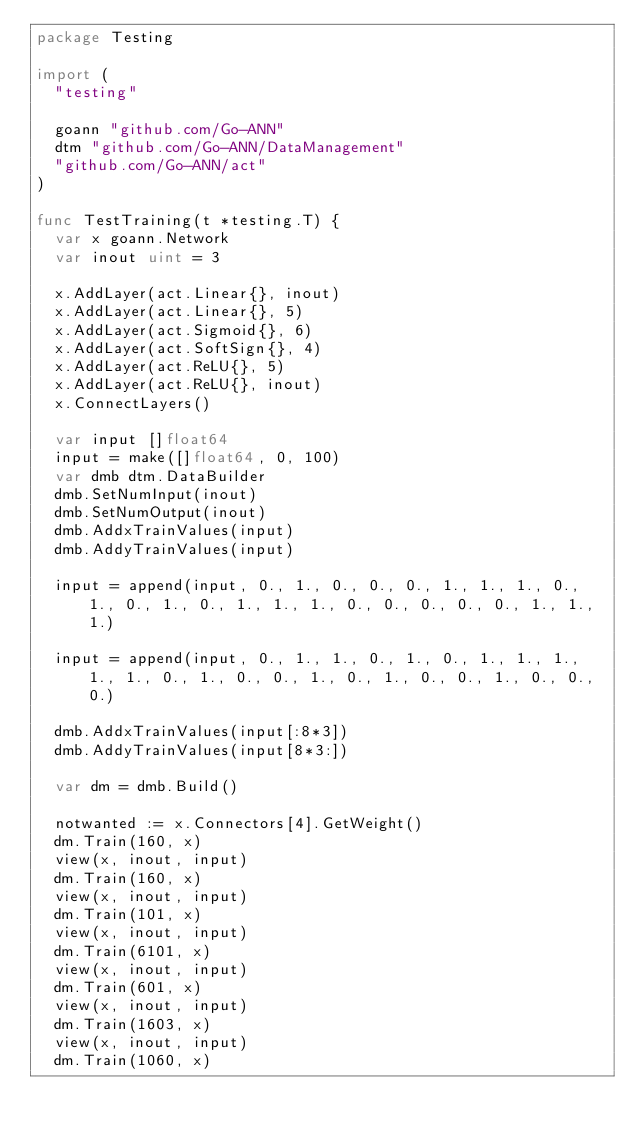Convert code to text. <code><loc_0><loc_0><loc_500><loc_500><_Go_>package Testing

import (
	"testing"

	goann "github.com/Go-ANN"
	dtm "github.com/Go-ANN/DataManagement"
	"github.com/Go-ANN/act"
)

func TestTraining(t *testing.T) {
	var x goann.Network
	var inout uint = 3

	x.AddLayer(act.Linear{}, inout)
	x.AddLayer(act.Linear{}, 5)
	x.AddLayer(act.Sigmoid{}, 6)
	x.AddLayer(act.SoftSign{}, 4)
	x.AddLayer(act.ReLU{}, 5)
	x.AddLayer(act.ReLU{}, inout)
	x.ConnectLayers()

	var input []float64
	input = make([]float64, 0, 100)
	var dmb dtm.DataBuilder
	dmb.SetNumInput(inout)
	dmb.SetNumOutput(inout)
	dmb.AddxTrainValues(input)
	dmb.AddyTrainValues(input)

	input = append(input, 0., 1., 0., 0., 0., 1., 1., 1., 0., 1., 0., 1., 0., 1., 1., 1., 0., 0., 0., 0., 0., 1., 1., 1.)

	input = append(input, 0., 1., 1., 0., 1., 0., 1., 1., 1., 1., 1., 0., 1., 0., 0., 1., 0., 1., 0., 0., 1., 0., 0., 0.)

	dmb.AddxTrainValues(input[:8*3])
	dmb.AddyTrainValues(input[8*3:])

	var dm = dmb.Build()

	notwanted := x.Connectors[4].GetWeight()
	dm.Train(160, x)
	view(x, inout, input)
	dm.Train(160, x)
	view(x, inout, input)
	dm.Train(101, x)
	view(x, inout, input)
	dm.Train(6101, x)
	view(x, inout, input)
	dm.Train(601, x)
	view(x, inout, input)
	dm.Train(1603, x)
	view(x, inout, input)
	dm.Train(1060, x)</code> 